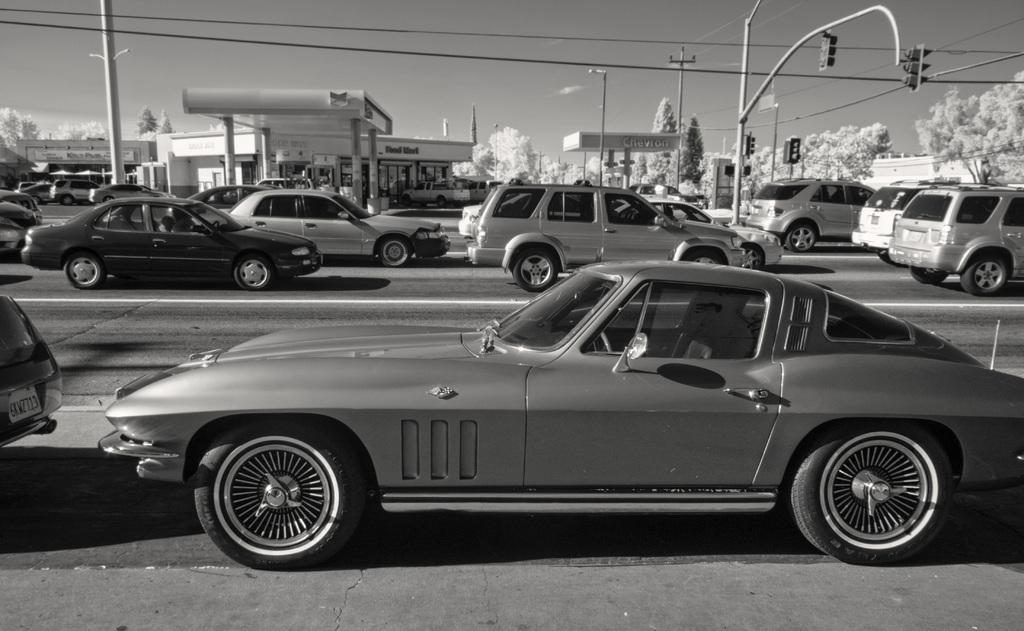What is the color scheme of the image? The image is black and white. What can be seen on the road in the image? There are cars on the road in the image. What are the traffic signals mounted on in the image? The traffic signals are mounted on poles in the image. What else can be seen in the image besides the cars and traffic signals? There are wires, a building, trees, poles, and the sky visible in the image. Where is the unit being held in the image? There is no unit or meeting present in the image; it features a black and white scene with cars, traffic signals, wires, a building, trees, poles, and the sky. 